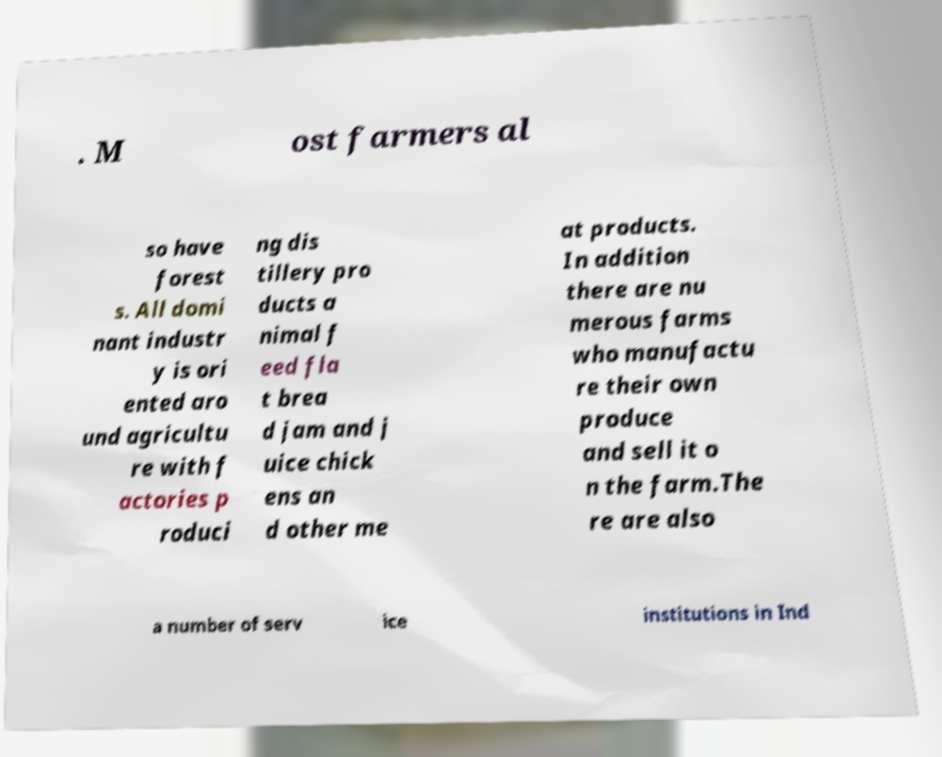Can you read and provide the text displayed in the image?This photo seems to have some interesting text. Can you extract and type it out for me? . M ost farmers al so have forest s. All domi nant industr y is ori ented aro und agricultu re with f actories p roduci ng dis tillery pro ducts a nimal f eed fla t brea d jam and j uice chick ens an d other me at products. In addition there are nu merous farms who manufactu re their own produce and sell it o n the farm.The re are also a number of serv ice institutions in Ind 